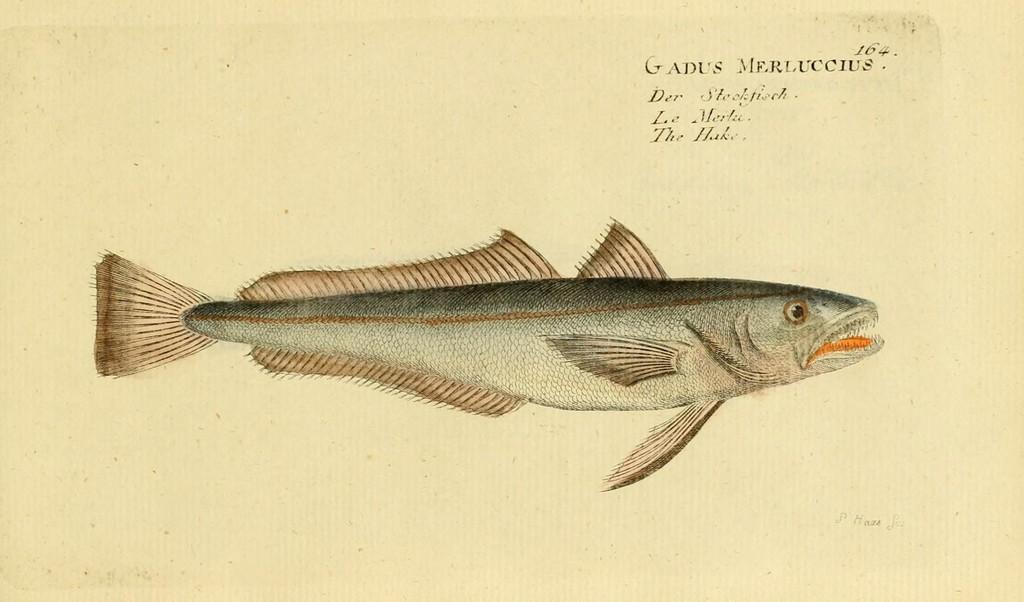What is the main subject of the painting in the image? The main subject of the painting in the image is a fish. Where is the text located in the image? The text is in the top right corner of the image. What type of advertisement is displayed on the fish's throat in the image? There is no advertisement or throat present on the fish in the image; it is a painting of a fish with no additional elements. 